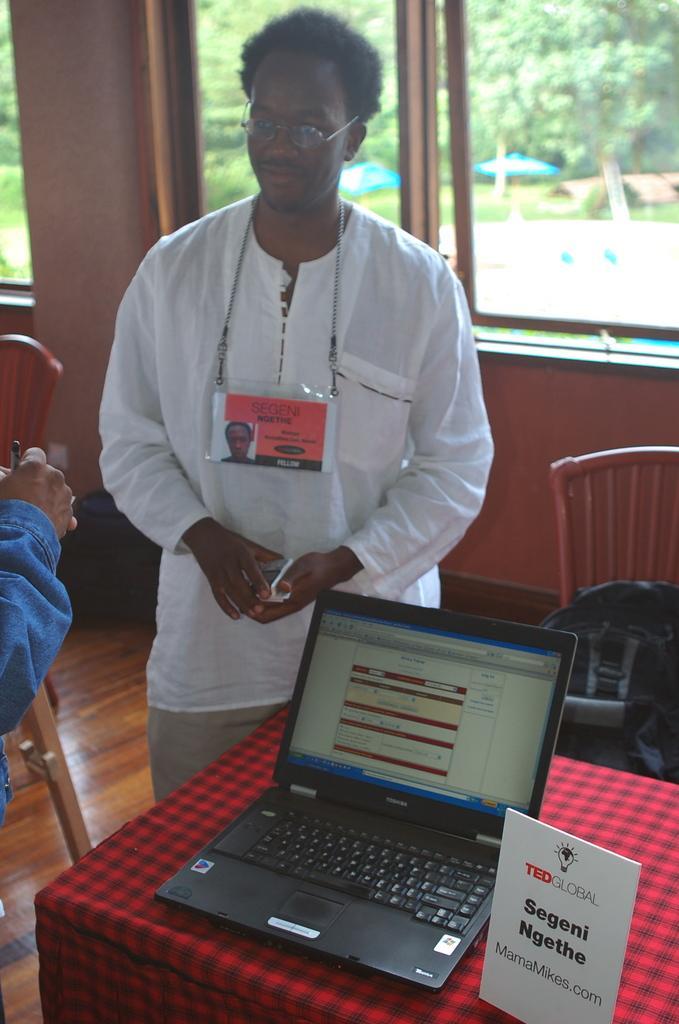Could you give a brief overview of what you see in this image? In the picture there is a man stood beside a man stood beside a table on which there is a laptop and background of him there are chairs and over the wall there is glass window. 